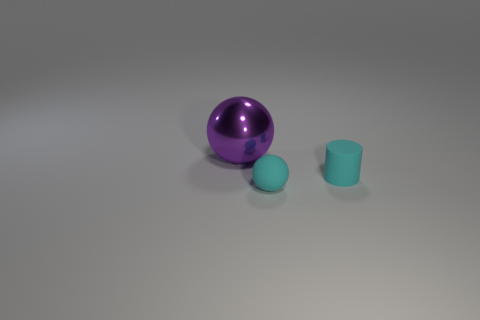Are there any other things that have the same size as the cyan rubber cylinder?
Provide a short and direct response. Yes. Are there the same number of tiny balls behind the large purple shiny thing and big things behind the small cyan rubber sphere?
Give a very brief answer. No. There is another rubber object that is the same shape as the big thing; what color is it?
Provide a short and direct response. Cyan. What number of rubber objects are the same color as the small sphere?
Offer a terse response. 1. There is a thing that is in front of the small matte cylinder; does it have the same shape as the metal object?
Make the answer very short. Yes. There is a object that is in front of the cyan thing that is on the right side of the ball that is right of the large purple metal sphere; what is its shape?
Make the answer very short. Sphere. What size is the purple ball?
Your answer should be compact. Large. The small ball that is the same material as the cylinder is what color?
Your answer should be very brief. Cyan. How many small cyan things are made of the same material as the cylinder?
Provide a short and direct response. 1. There is a matte ball; does it have the same color as the object that is on the right side of the tiny cyan ball?
Ensure brevity in your answer.  Yes. 